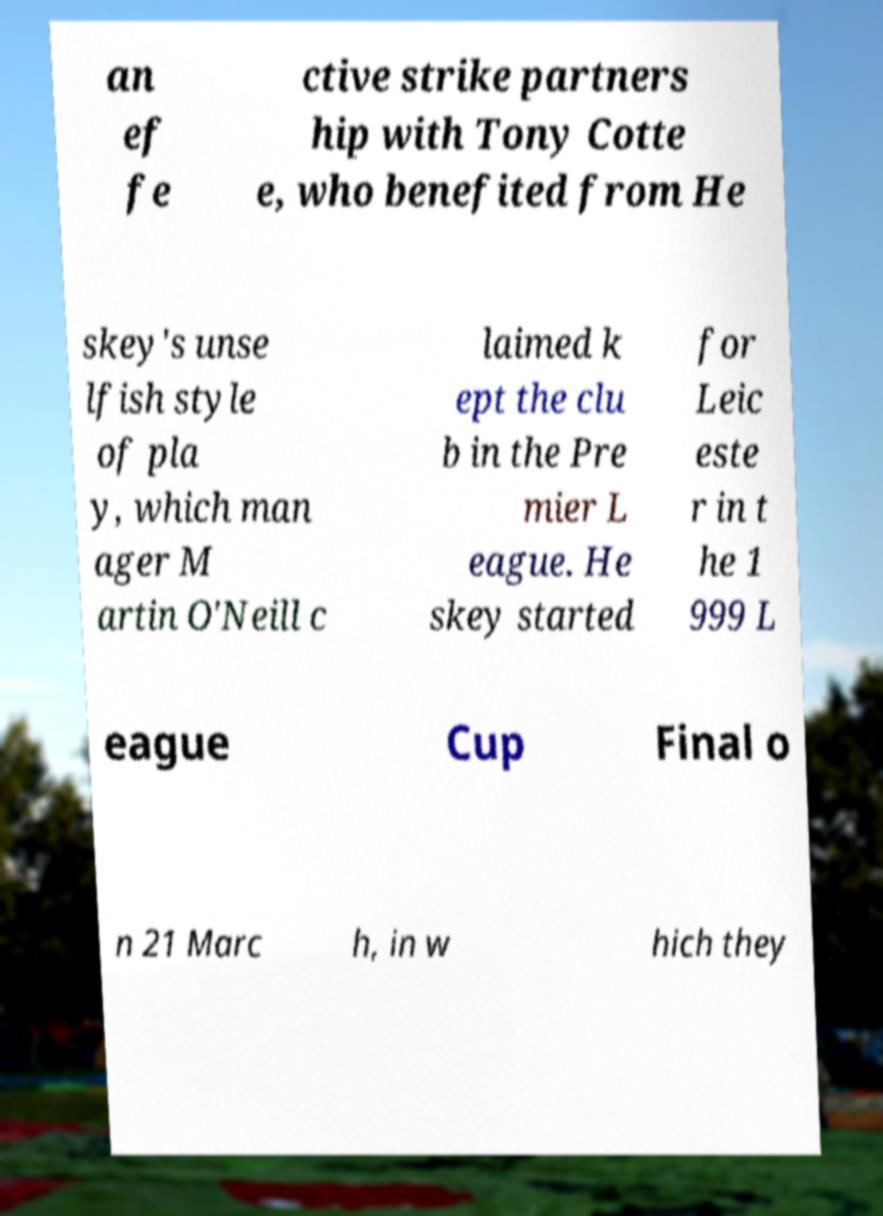Please identify and transcribe the text found in this image. an ef fe ctive strike partners hip with Tony Cotte e, who benefited from He skey's unse lfish style of pla y, which man ager M artin O'Neill c laimed k ept the clu b in the Pre mier L eague. He skey started for Leic este r in t he 1 999 L eague Cup Final o n 21 Marc h, in w hich they 